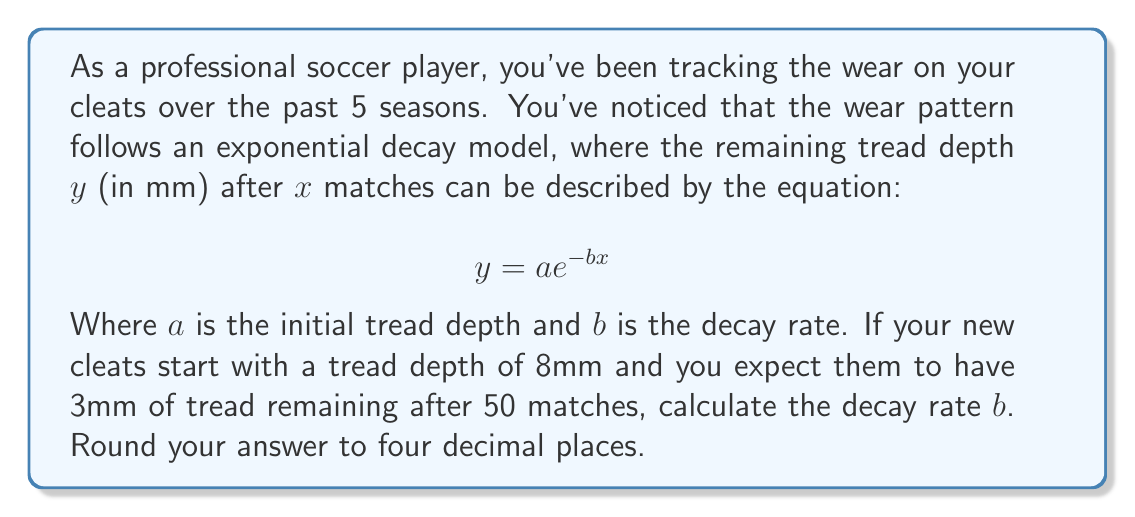Can you answer this question? To solve this problem, we'll use the given exponential decay model and the information provided:

1. Initial tread depth $a = 8$ mm
2. After 50 matches $(x = 50)$, the remaining tread depth $y = 3$ mm

Let's substitute these values into the equation:

$$3 = 8e^{-b(50)}$$

Now we need to solve for $b$:

1. Divide both sides by 8:
   $$\frac{3}{8} = e^{-50b}$$

2. Take the natural logarithm of both sides:
   $$\ln(\frac{3}{8}) = \ln(e^{-50b})$$

3. Simplify the right side using the properties of logarithms:
   $$\ln(\frac{3}{8}) = -50b$$

4. Solve for $b$:
   $$b = -\frac{1}{50}\ln(\frac{3}{8})$$

5. Calculate the value:
   $$b = -\frac{1}{50}(\ln(3) - \ln(8))$$
   $$b = -\frac{1}{50}(1.0986 - 2.0794)$$
   $$b = -\frac{1}{50}(-0.9808)$$
   $$b = 0.019616$$

6. Round to four decimal places:
   $$b \approx 0.0196$$
Answer: $b \approx 0.0196$ 